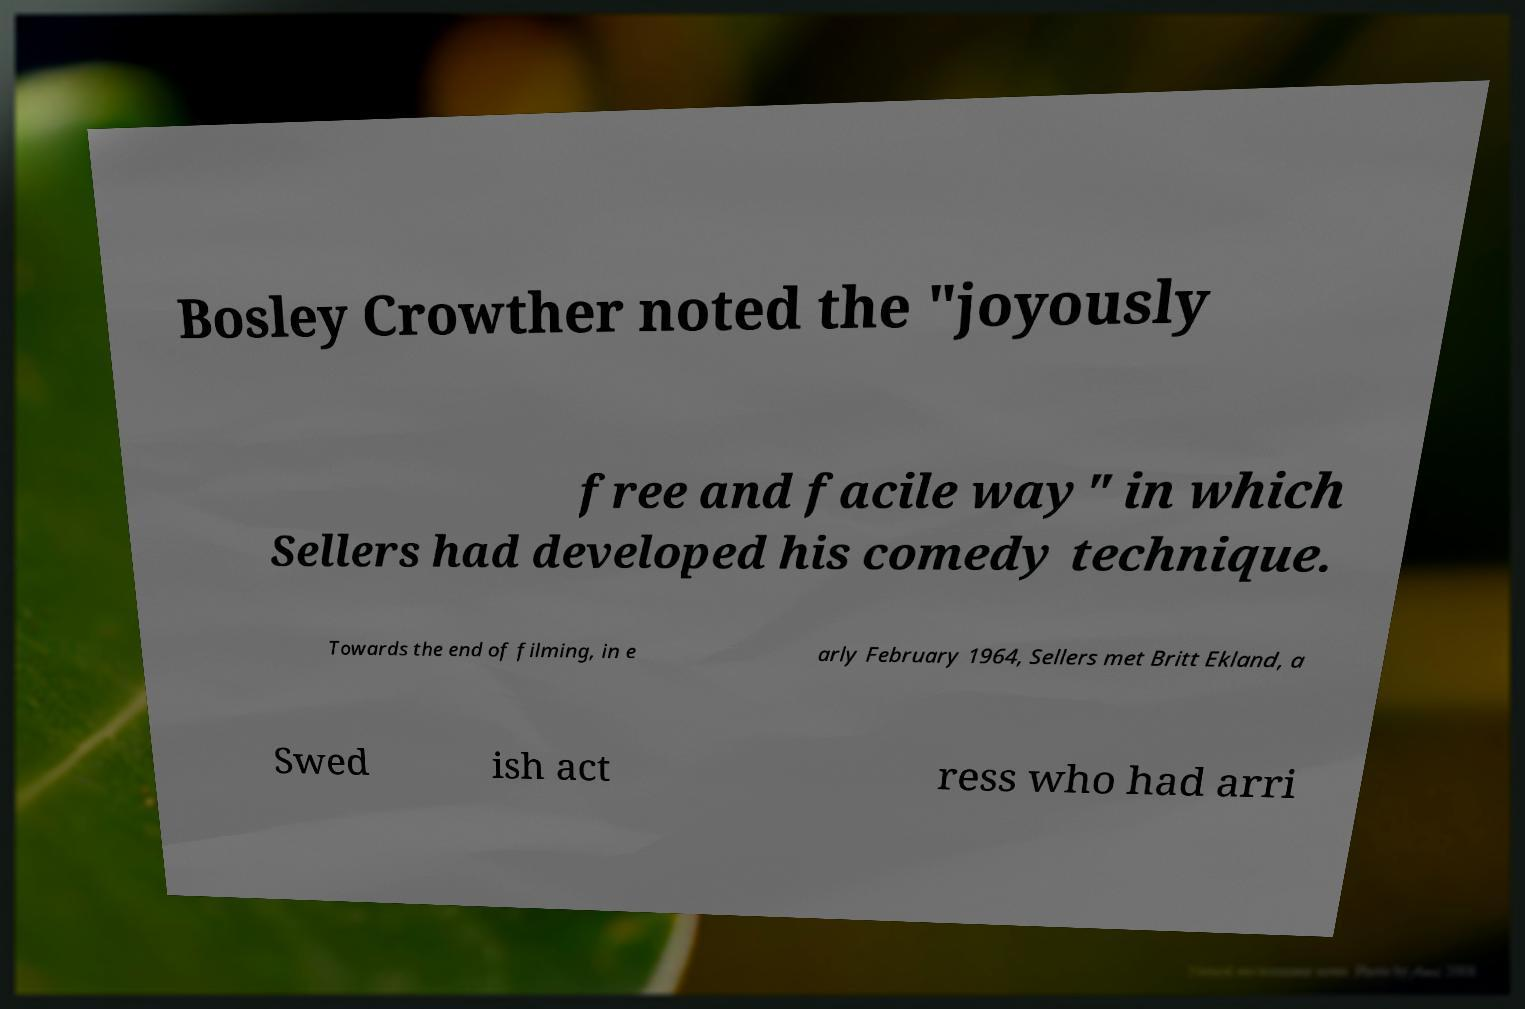Please identify and transcribe the text found in this image. Bosley Crowther noted the "joyously free and facile way" in which Sellers had developed his comedy technique. Towards the end of filming, in e arly February 1964, Sellers met Britt Ekland, a Swed ish act ress who had arri 